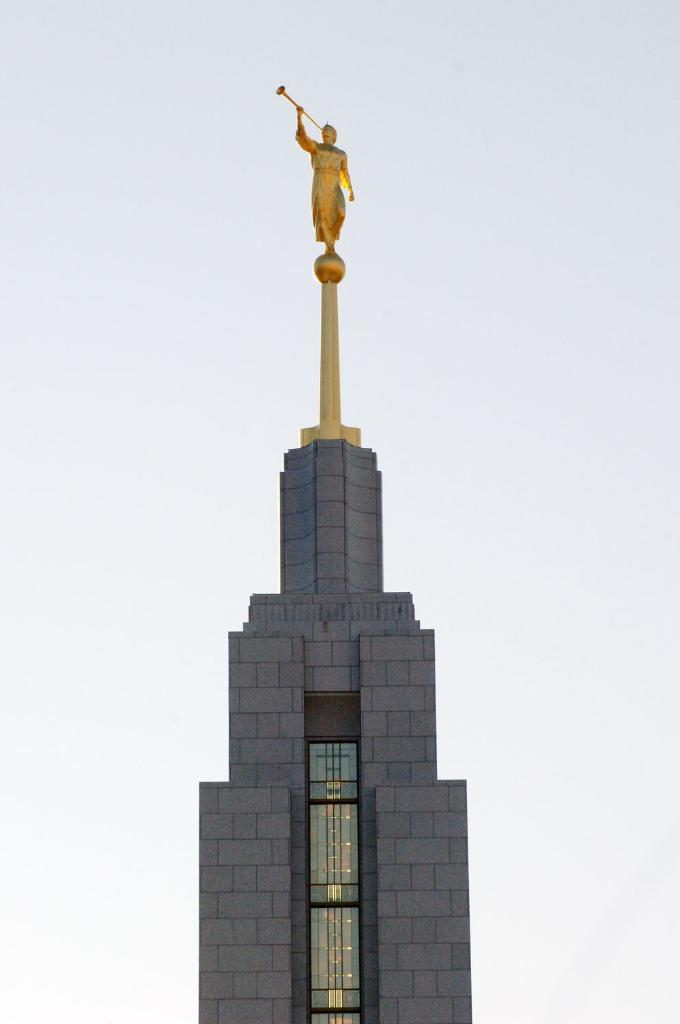What is the main structure visible in the image? There is a building in the image. Is there any additional feature on top of the building? Yes, there is a sculpture on top of the building. What can be seen in the background of the image? The sky is visible in the background of the image. What type of curve can be seen in the sculpture on top of the building? There is no curve mentioned or visible in the sculpture on top of the building in the image. 